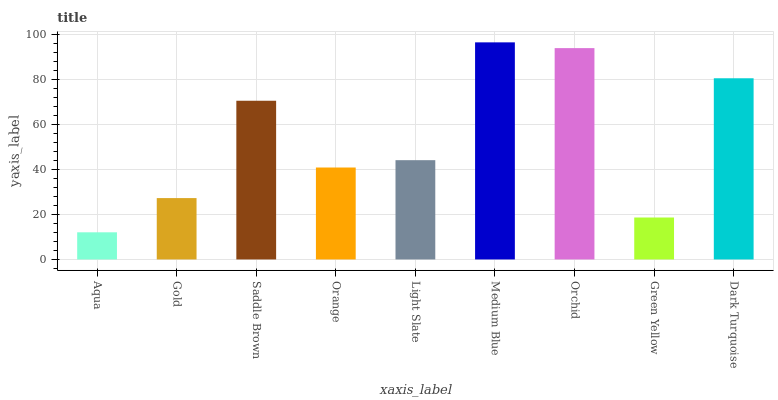Is Aqua the minimum?
Answer yes or no. Yes. Is Medium Blue the maximum?
Answer yes or no. Yes. Is Gold the minimum?
Answer yes or no. No. Is Gold the maximum?
Answer yes or no. No. Is Gold greater than Aqua?
Answer yes or no. Yes. Is Aqua less than Gold?
Answer yes or no. Yes. Is Aqua greater than Gold?
Answer yes or no. No. Is Gold less than Aqua?
Answer yes or no. No. Is Light Slate the high median?
Answer yes or no. Yes. Is Light Slate the low median?
Answer yes or no. Yes. Is Green Yellow the high median?
Answer yes or no. No. Is Orchid the low median?
Answer yes or no. No. 